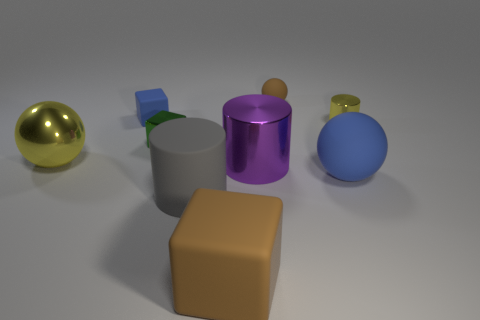There is a green object; how many small green things are right of it?
Offer a very short reply. 0. Are there an equal number of tiny yellow cylinders in front of the large blue matte thing and blue blocks to the right of the large brown object?
Ensure brevity in your answer.  Yes. What size is the purple object that is the same shape as the gray thing?
Keep it short and to the point. Large. The metallic thing behind the shiny block has what shape?
Your answer should be compact. Cylinder. Do the small cube in front of the blue block and the brown object that is behind the small yellow cylinder have the same material?
Provide a short and direct response. No. What is the shape of the large blue thing?
Provide a short and direct response. Sphere. Is the number of big metallic things that are in front of the large yellow metallic ball the same as the number of big balls?
Your answer should be compact. No. The matte object that is the same color as the small rubber block is what size?
Ensure brevity in your answer.  Large. Is there a large cylinder that has the same material as the brown sphere?
Your response must be concise. Yes. There is a brown thing in front of the blue rubber sphere; is its shape the same as the metallic object right of the brown ball?
Give a very brief answer. No. 